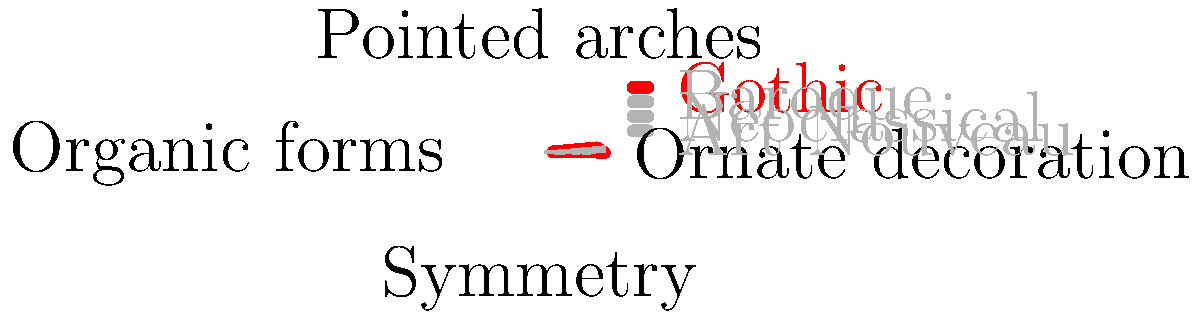Based on the radar chart showing architectural features, which historical building style is highlighted in red and what is its most prominent characteristic? To answer this question, let's analyze the radar chart step-by-step:

1. The chart displays four architectural styles: Gothic, Baroque, Neoclassical, and Art Nouveau.

2. Each style is represented by a shape on the chart, with four axes representing different architectural features:
   - Pointed arches (top)
   - Ornate decoration (right)
   - Symmetry (bottom)
   - Organic forms (left)

3. The style highlighted in red is the most prominent in the chart.

4. Looking at the red shape, we can see that it extends furthest on two axes:
   - Pointed arches (top)
   - Organic forms (left)

5. Of these two features, the pointed arches axis shows the highest value for the red shape.

6. Referring to the legend, we can identify that the red shape represents the Gothic style.

7. Gothic architecture is indeed known for its distinctive pointed arches, which is consistent with the chart.

Therefore, the architectural style highlighted in red is Gothic, and its most prominent characteristic, according to the chart, is pointed arches.
Answer: Gothic; pointed arches 